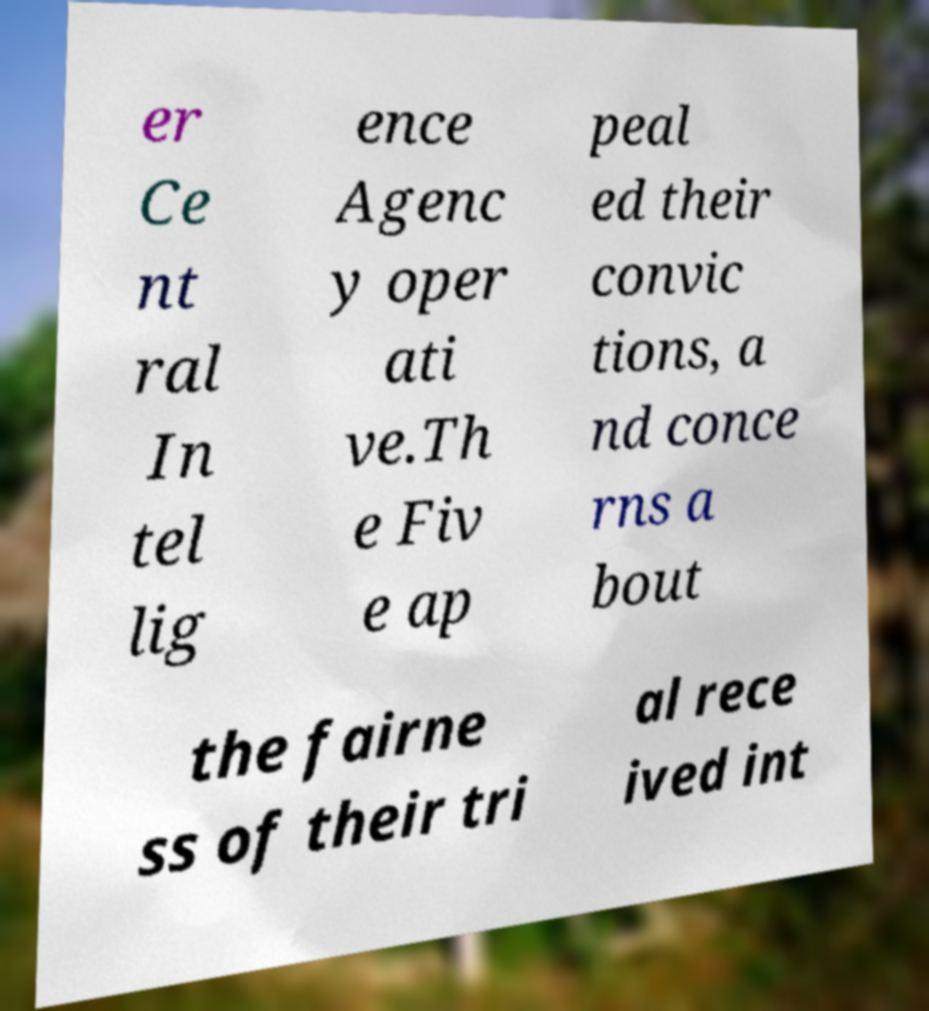For documentation purposes, I need the text within this image transcribed. Could you provide that? er Ce nt ral In tel lig ence Agenc y oper ati ve.Th e Fiv e ap peal ed their convic tions, a nd conce rns a bout the fairne ss of their tri al rece ived int 